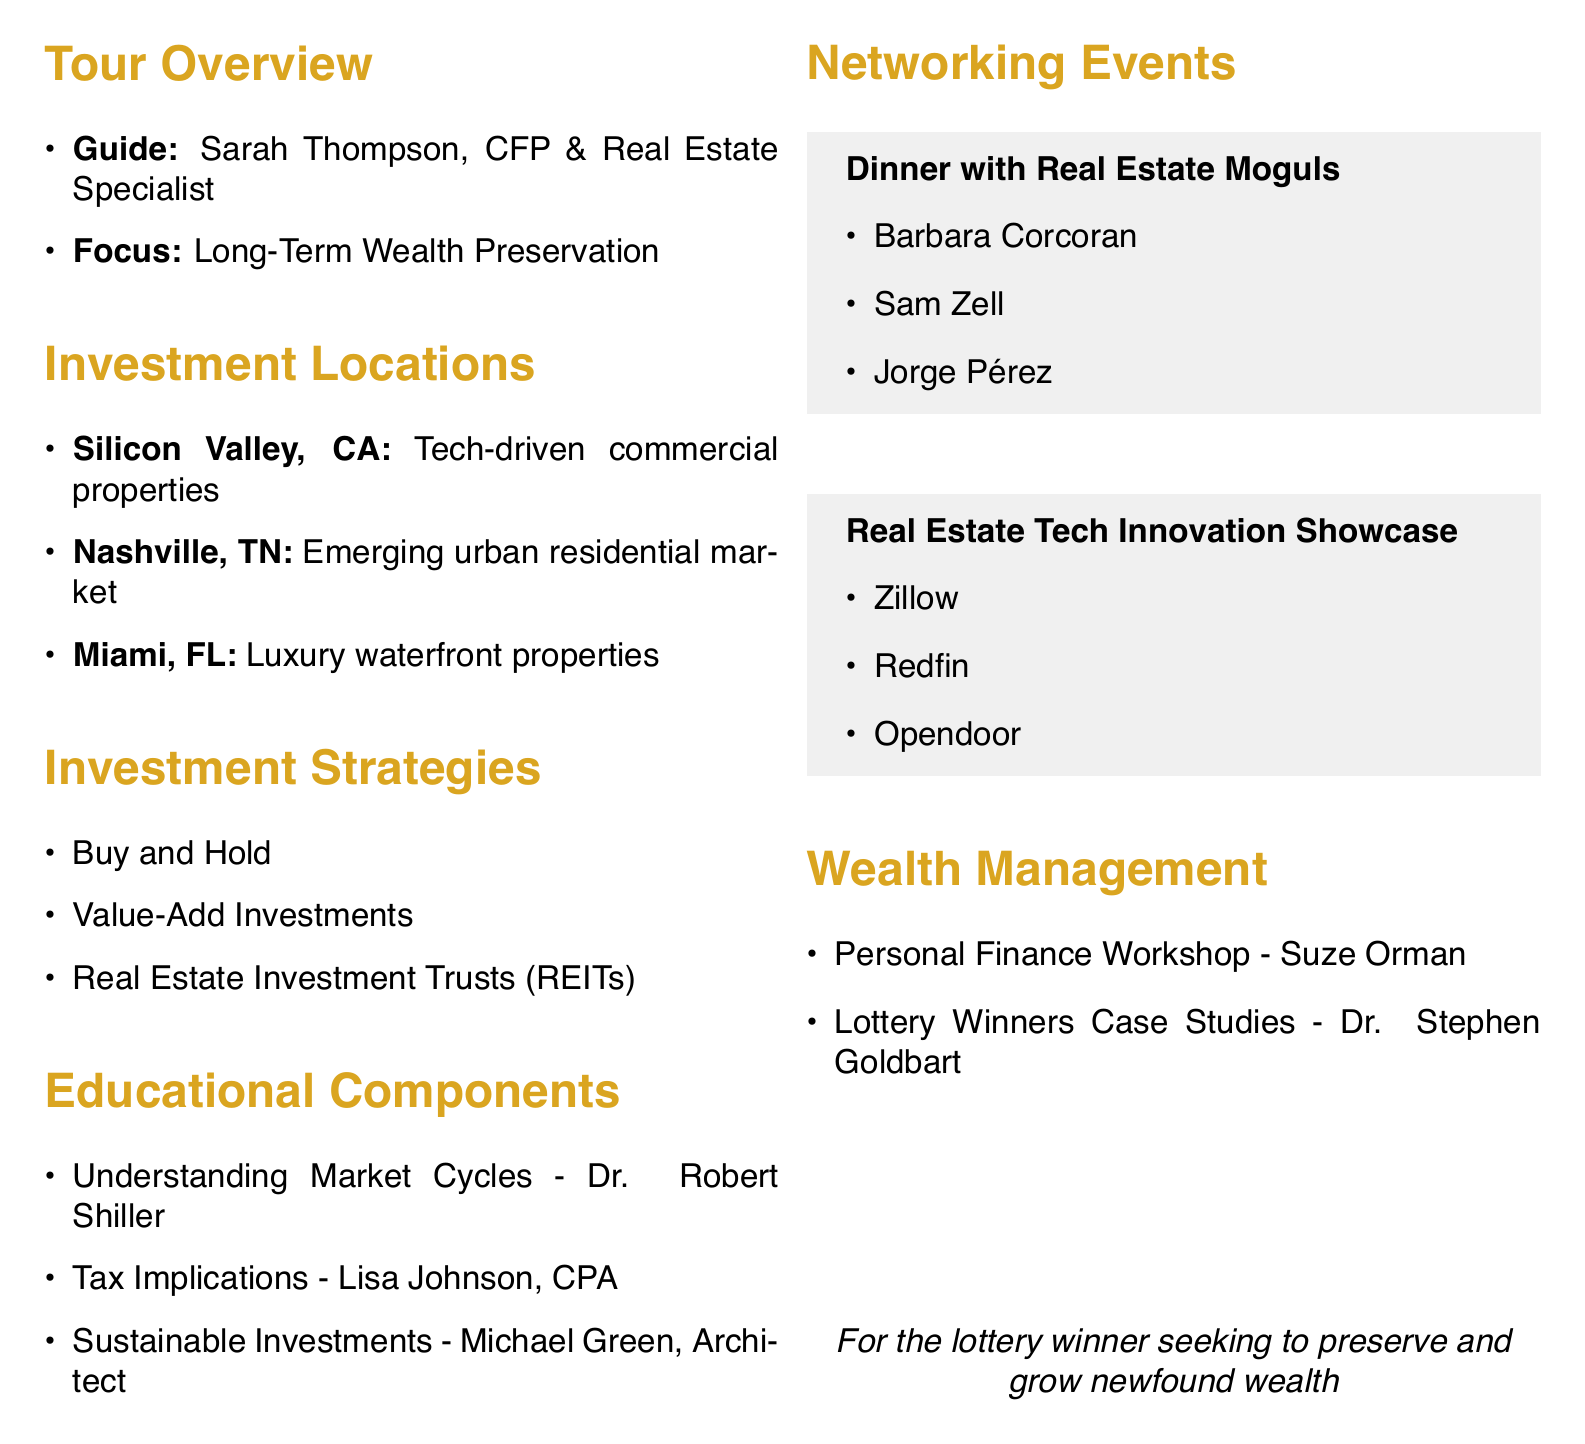what is the title of the tour? The title of the tour is listed in the document under "tour_overview."
Answer: Exploring High-Potential Real Estate Investments for Long-Term Wealth Preservation who is the guide for the tour? The guide's name is mentioned in the "tour_overview" section of the document.
Answer: Sarah Thompson how many days will the tour last? The duration of the tour is specified in the "tour_overview."
Answer: 3 days which location is focused on tech-driven commercial properties? The specific location focusing on tech-driven commercial properties is found in the "tour_locations" section.
Answer: Silicon Valley, California what investment strategy involves purchasing properties for long-term ownership? The investment strategy that involves long-term ownership is found in the "investment_strategies" section.
Answer: Buy and Hold who is presenting on tax implications for real estate investors? The presenter for tax implications is mentioned under "educational_components."
Answer: Lisa Johnson what is one of the topics covered in the Personal Finance Workshop? The topics covered in the Personal Finance Workshop are listed in the "wealth_management_resources."
Answer: Creating a balanced portfolio what will attendees learn about from Dr. Robert Shiller? The key topics of Dr. Shiller's presentation are found in the "educational_components" section.
Answer: Historical real estate bubbles and crashes where will the dinner with successful real estate moguls take place? The venue for the networking event is mentioned in "networking_events."
Answer: The Capital Grille, New York City 